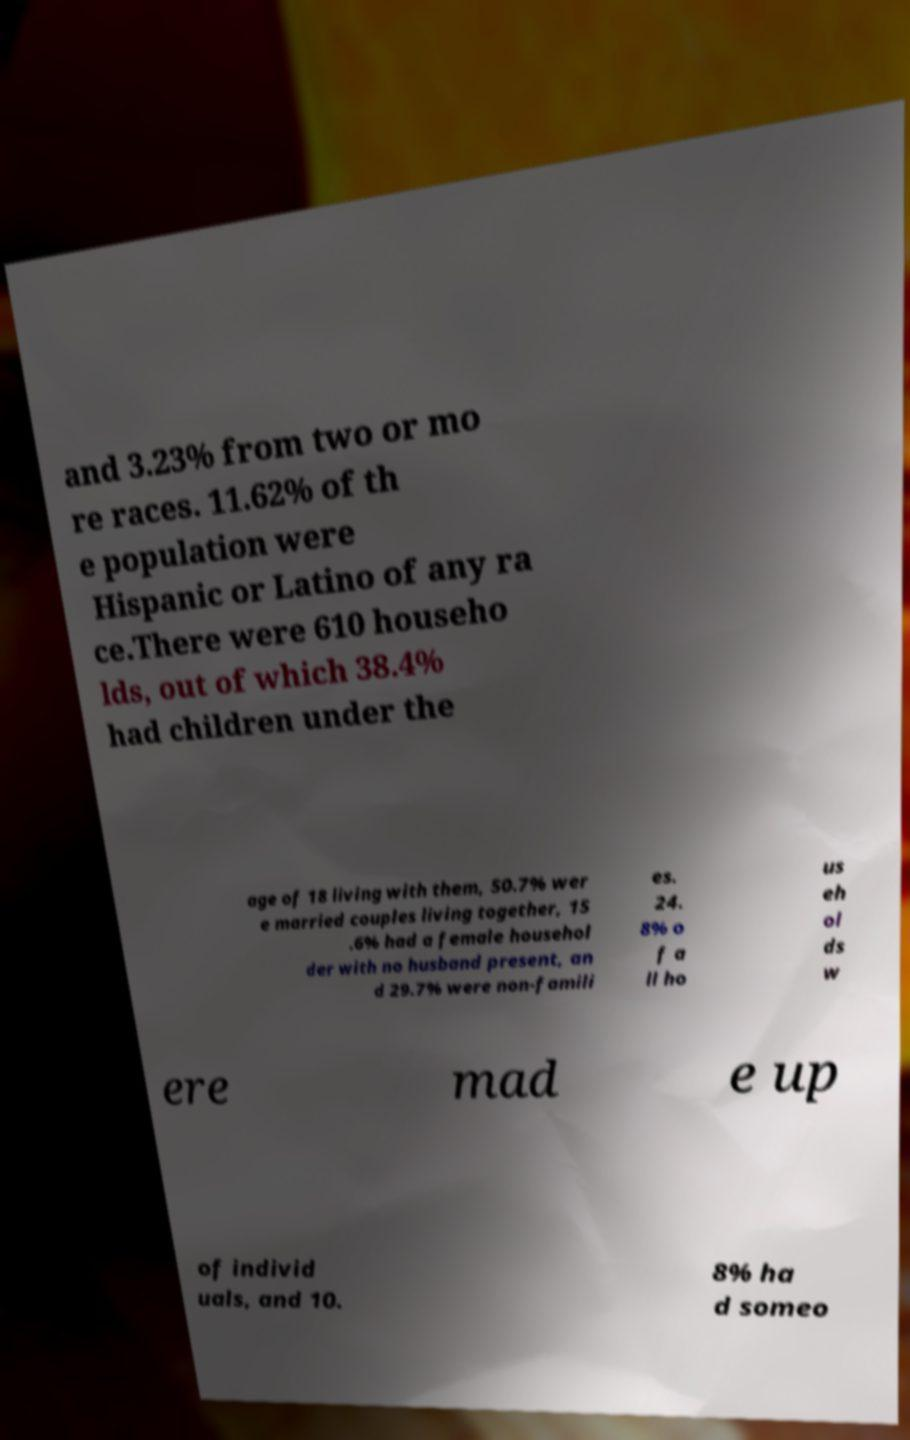Please read and relay the text visible in this image. What does it say? and 3.23% from two or mo re races. 11.62% of th e population were Hispanic or Latino of any ra ce.There were 610 househo lds, out of which 38.4% had children under the age of 18 living with them, 50.7% wer e married couples living together, 15 .6% had a female househol der with no husband present, an d 29.7% were non-famili es. 24. 8% o f a ll ho us eh ol ds w ere mad e up of individ uals, and 10. 8% ha d someo 